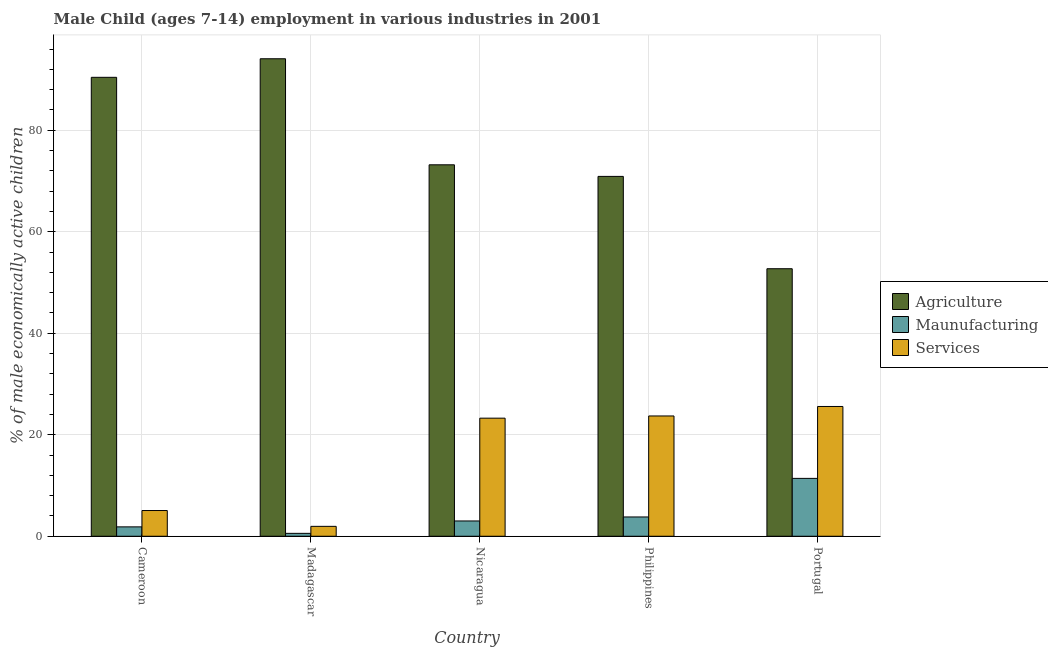How many different coloured bars are there?
Your response must be concise. 3. How many bars are there on the 2nd tick from the right?
Your response must be concise. 3. What is the label of the 1st group of bars from the left?
Ensure brevity in your answer.  Cameroon. In how many cases, is the number of bars for a given country not equal to the number of legend labels?
Offer a terse response. 0. What is the percentage of economically active children in services in Cameroon?
Offer a terse response. 5.07. Across all countries, what is the maximum percentage of economically active children in services?
Make the answer very short. 25.57. Across all countries, what is the minimum percentage of economically active children in services?
Keep it short and to the point. 1.95. In which country was the percentage of economically active children in agriculture maximum?
Make the answer very short. Madagascar. What is the total percentage of economically active children in manufacturing in the graph?
Keep it short and to the point. 20.63. What is the difference between the percentage of economically active children in agriculture in Cameroon and that in Portugal?
Offer a terse response. 37.71. What is the difference between the percentage of economically active children in services in Madagascar and the percentage of economically active children in manufacturing in Cameroon?
Provide a short and direct response. 0.1. What is the average percentage of economically active children in agriculture per country?
Make the answer very short. 76.26. What is the difference between the percentage of economically active children in manufacturing and percentage of economically active children in agriculture in Cameroon?
Your answer should be very brief. -88.57. In how many countries, is the percentage of economically active children in agriculture greater than 16 %?
Give a very brief answer. 5. What is the ratio of the percentage of economically active children in agriculture in Nicaragua to that in Portugal?
Ensure brevity in your answer.  1.39. Is the difference between the percentage of economically active children in manufacturing in Madagascar and Nicaragua greater than the difference between the percentage of economically active children in agriculture in Madagascar and Nicaragua?
Provide a short and direct response. No. What is the difference between the highest and the second highest percentage of economically active children in manufacturing?
Make the answer very short. 7.6. What is the difference between the highest and the lowest percentage of economically active children in agriculture?
Your answer should be compact. 41.37. Is the sum of the percentage of economically active children in agriculture in Cameroon and Nicaragua greater than the maximum percentage of economically active children in manufacturing across all countries?
Your answer should be very brief. Yes. What does the 2nd bar from the left in Madagascar represents?
Your response must be concise. Maunufacturing. What does the 2nd bar from the right in Cameroon represents?
Ensure brevity in your answer.  Maunufacturing. Is it the case that in every country, the sum of the percentage of economically active children in agriculture and percentage of economically active children in manufacturing is greater than the percentage of economically active children in services?
Provide a short and direct response. Yes. How many countries are there in the graph?
Ensure brevity in your answer.  5. What is the difference between two consecutive major ticks on the Y-axis?
Ensure brevity in your answer.  20. Does the graph contain any zero values?
Your response must be concise. No. Does the graph contain grids?
Make the answer very short. Yes. How are the legend labels stacked?
Provide a short and direct response. Vertical. What is the title of the graph?
Provide a short and direct response. Male Child (ages 7-14) employment in various industries in 2001. What is the label or title of the X-axis?
Keep it short and to the point. Country. What is the label or title of the Y-axis?
Your answer should be very brief. % of male economically active children. What is the % of male economically active children of Agriculture in Cameroon?
Your answer should be compact. 90.42. What is the % of male economically active children of Maunufacturing in Cameroon?
Offer a terse response. 1.85. What is the % of male economically active children of Services in Cameroon?
Give a very brief answer. 5.07. What is the % of male economically active children in Agriculture in Madagascar?
Make the answer very short. 94.08. What is the % of male economically active children in Maunufacturing in Madagascar?
Provide a short and direct response. 0.57. What is the % of male economically active children of Services in Madagascar?
Provide a succinct answer. 1.95. What is the % of male economically active children of Agriculture in Nicaragua?
Make the answer very short. 73.19. What is the % of male economically active children of Maunufacturing in Nicaragua?
Your answer should be very brief. 3.01. What is the % of male economically active children of Services in Nicaragua?
Offer a very short reply. 23.27. What is the % of male economically active children in Agriculture in Philippines?
Keep it short and to the point. 70.9. What is the % of male economically active children in Maunufacturing in Philippines?
Your answer should be very brief. 3.8. What is the % of male economically active children in Services in Philippines?
Provide a succinct answer. 23.7. What is the % of male economically active children of Agriculture in Portugal?
Offer a terse response. 52.71. What is the % of male economically active children of Maunufacturing in Portugal?
Your answer should be compact. 11.4. What is the % of male economically active children in Services in Portugal?
Give a very brief answer. 25.57. Across all countries, what is the maximum % of male economically active children in Agriculture?
Ensure brevity in your answer.  94.08. Across all countries, what is the maximum % of male economically active children in Maunufacturing?
Provide a short and direct response. 11.4. Across all countries, what is the maximum % of male economically active children in Services?
Your answer should be very brief. 25.57. Across all countries, what is the minimum % of male economically active children in Agriculture?
Your answer should be very brief. 52.71. Across all countries, what is the minimum % of male economically active children of Maunufacturing?
Offer a terse response. 0.57. Across all countries, what is the minimum % of male economically active children of Services?
Offer a very short reply. 1.95. What is the total % of male economically active children of Agriculture in the graph?
Give a very brief answer. 381.3. What is the total % of male economically active children of Maunufacturing in the graph?
Your response must be concise. 20.63. What is the total % of male economically active children in Services in the graph?
Give a very brief answer. 79.56. What is the difference between the % of male economically active children of Agriculture in Cameroon and that in Madagascar?
Make the answer very short. -3.66. What is the difference between the % of male economically active children of Maunufacturing in Cameroon and that in Madagascar?
Provide a short and direct response. 1.28. What is the difference between the % of male economically active children in Services in Cameroon and that in Madagascar?
Provide a succinct answer. 3.12. What is the difference between the % of male economically active children of Agriculture in Cameroon and that in Nicaragua?
Make the answer very short. 17.23. What is the difference between the % of male economically active children in Maunufacturing in Cameroon and that in Nicaragua?
Keep it short and to the point. -1.16. What is the difference between the % of male economically active children of Services in Cameroon and that in Nicaragua?
Your answer should be very brief. -18.2. What is the difference between the % of male economically active children in Agriculture in Cameroon and that in Philippines?
Provide a short and direct response. 19.52. What is the difference between the % of male economically active children in Maunufacturing in Cameroon and that in Philippines?
Your response must be concise. -1.95. What is the difference between the % of male economically active children of Services in Cameroon and that in Philippines?
Your answer should be very brief. -18.63. What is the difference between the % of male economically active children of Agriculture in Cameroon and that in Portugal?
Ensure brevity in your answer.  37.71. What is the difference between the % of male economically active children of Maunufacturing in Cameroon and that in Portugal?
Offer a very short reply. -9.55. What is the difference between the % of male economically active children of Services in Cameroon and that in Portugal?
Ensure brevity in your answer.  -20.5. What is the difference between the % of male economically active children of Agriculture in Madagascar and that in Nicaragua?
Your response must be concise. 20.89. What is the difference between the % of male economically active children in Maunufacturing in Madagascar and that in Nicaragua?
Give a very brief answer. -2.44. What is the difference between the % of male economically active children of Services in Madagascar and that in Nicaragua?
Your answer should be compact. -21.32. What is the difference between the % of male economically active children of Agriculture in Madagascar and that in Philippines?
Keep it short and to the point. 23.18. What is the difference between the % of male economically active children of Maunufacturing in Madagascar and that in Philippines?
Your response must be concise. -3.23. What is the difference between the % of male economically active children of Services in Madagascar and that in Philippines?
Your answer should be compact. -21.75. What is the difference between the % of male economically active children of Agriculture in Madagascar and that in Portugal?
Your response must be concise. 41.37. What is the difference between the % of male economically active children of Maunufacturing in Madagascar and that in Portugal?
Make the answer very short. -10.83. What is the difference between the % of male economically active children of Services in Madagascar and that in Portugal?
Make the answer very short. -23.62. What is the difference between the % of male economically active children of Agriculture in Nicaragua and that in Philippines?
Offer a very short reply. 2.29. What is the difference between the % of male economically active children of Maunufacturing in Nicaragua and that in Philippines?
Offer a terse response. -0.79. What is the difference between the % of male economically active children in Services in Nicaragua and that in Philippines?
Your answer should be compact. -0.43. What is the difference between the % of male economically active children in Agriculture in Nicaragua and that in Portugal?
Keep it short and to the point. 20.48. What is the difference between the % of male economically active children of Maunufacturing in Nicaragua and that in Portugal?
Keep it short and to the point. -8.39. What is the difference between the % of male economically active children of Services in Nicaragua and that in Portugal?
Provide a succinct answer. -2.3. What is the difference between the % of male economically active children in Agriculture in Philippines and that in Portugal?
Your answer should be very brief. 18.19. What is the difference between the % of male economically active children in Maunufacturing in Philippines and that in Portugal?
Your answer should be compact. -7.6. What is the difference between the % of male economically active children of Services in Philippines and that in Portugal?
Offer a very short reply. -1.87. What is the difference between the % of male economically active children in Agriculture in Cameroon and the % of male economically active children in Maunufacturing in Madagascar?
Keep it short and to the point. 89.85. What is the difference between the % of male economically active children in Agriculture in Cameroon and the % of male economically active children in Services in Madagascar?
Ensure brevity in your answer.  88.47. What is the difference between the % of male economically active children in Maunufacturing in Cameroon and the % of male economically active children in Services in Madagascar?
Your answer should be compact. -0.1. What is the difference between the % of male economically active children of Agriculture in Cameroon and the % of male economically active children of Maunufacturing in Nicaragua?
Ensure brevity in your answer.  87.41. What is the difference between the % of male economically active children in Agriculture in Cameroon and the % of male economically active children in Services in Nicaragua?
Ensure brevity in your answer.  67.15. What is the difference between the % of male economically active children of Maunufacturing in Cameroon and the % of male economically active children of Services in Nicaragua?
Give a very brief answer. -21.42. What is the difference between the % of male economically active children of Agriculture in Cameroon and the % of male economically active children of Maunufacturing in Philippines?
Your answer should be very brief. 86.62. What is the difference between the % of male economically active children of Agriculture in Cameroon and the % of male economically active children of Services in Philippines?
Offer a terse response. 66.72. What is the difference between the % of male economically active children of Maunufacturing in Cameroon and the % of male economically active children of Services in Philippines?
Your answer should be very brief. -21.85. What is the difference between the % of male economically active children of Agriculture in Cameroon and the % of male economically active children of Maunufacturing in Portugal?
Provide a short and direct response. 79.02. What is the difference between the % of male economically active children in Agriculture in Cameroon and the % of male economically active children in Services in Portugal?
Keep it short and to the point. 64.85. What is the difference between the % of male economically active children of Maunufacturing in Cameroon and the % of male economically active children of Services in Portugal?
Ensure brevity in your answer.  -23.72. What is the difference between the % of male economically active children in Agriculture in Madagascar and the % of male economically active children in Maunufacturing in Nicaragua?
Provide a succinct answer. 91.07. What is the difference between the % of male economically active children of Agriculture in Madagascar and the % of male economically active children of Services in Nicaragua?
Offer a terse response. 70.81. What is the difference between the % of male economically active children of Maunufacturing in Madagascar and the % of male economically active children of Services in Nicaragua?
Keep it short and to the point. -22.7. What is the difference between the % of male economically active children in Agriculture in Madagascar and the % of male economically active children in Maunufacturing in Philippines?
Provide a succinct answer. 90.28. What is the difference between the % of male economically active children of Agriculture in Madagascar and the % of male economically active children of Services in Philippines?
Keep it short and to the point. 70.38. What is the difference between the % of male economically active children of Maunufacturing in Madagascar and the % of male economically active children of Services in Philippines?
Your answer should be compact. -23.13. What is the difference between the % of male economically active children in Agriculture in Madagascar and the % of male economically active children in Maunufacturing in Portugal?
Ensure brevity in your answer.  82.68. What is the difference between the % of male economically active children of Agriculture in Madagascar and the % of male economically active children of Services in Portugal?
Make the answer very short. 68.51. What is the difference between the % of male economically active children of Maunufacturing in Madagascar and the % of male economically active children of Services in Portugal?
Your answer should be very brief. -25. What is the difference between the % of male economically active children of Agriculture in Nicaragua and the % of male economically active children of Maunufacturing in Philippines?
Ensure brevity in your answer.  69.39. What is the difference between the % of male economically active children of Agriculture in Nicaragua and the % of male economically active children of Services in Philippines?
Make the answer very short. 49.49. What is the difference between the % of male economically active children of Maunufacturing in Nicaragua and the % of male economically active children of Services in Philippines?
Give a very brief answer. -20.69. What is the difference between the % of male economically active children in Agriculture in Nicaragua and the % of male economically active children in Maunufacturing in Portugal?
Offer a very short reply. 61.78. What is the difference between the % of male economically active children of Agriculture in Nicaragua and the % of male economically active children of Services in Portugal?
Ensure brevity in your answer.  47.62. What is the difference between the % of male economically active children in Maunufacturing in Nicaragua and the % of male economically active children in Services in Portugal?
Your answer should be very brief. -22.56. What is the difference between the % of male economically active children of Agriculture in Philippines and the % of male economically active children of Maunufacturing in Portugal?
Offer a terse response. 59.5. What is the difference between the % of male economically active children in Agriculture in Philippines and the % of male economically active children in Services in Portugal?
Provide a short and direct response. 45.33. What is the difference between the % of male economically active children in Maunufacturing in Philippines and the % of male economically active children in Services in Portugal?
Provide a succinct answer. -21.77. What is the average % of male economically active children of Agriculture per country?
Ensure brevity in your answer.  76.26. What is the average % of male economically active children in Maunufacturing per country?
Offer a terse response. 4.13. What is the average % of male economically active children of Services per country?
Offer a very short reply. 15.91. What is the difference between the % of male economically active children of Agriculture and % of male economically active children of Maunufacturing in Cameroon?
Make the answer very short. 88.57. What is the difference between the % of male economically active children of Agriculture and % of male economically active children of Services in Cameroon?
Provide a short and direct response. 85.35. What is the difference between the % of male economically active children in Maunufacturing and % of male economically active children in Services in Cameroon?
Provide a succinct answer. -3.22. What is the difference between the % of male economically active children of Agriculture and % of male economically active children of Maunufacturing in Madagascar?
Your answer should be very brief. 93.51. What is the difference between the % of male economically active children in Agriculture and % of male economically active children in Services in Madagascar?
Give a very brief answer. 92.13. What is the difference between the % of male economically active children of Maunufacturing and % of male economically active children of Services in Madagascar?
Provide a short and direct response. -1.38. What is the difference between the % of male economically active children of Agriculture and % of male economically active children of Maunufacturing in Nicaragua?
Offer a very short reply. 70.17. What is the difference between the % of male economically active children of Agriculture and % of male economically active children of Services in Nicaragua?
Offer a terse response. 49.92. What is the difference between the % of male economically active children of Maunufacturing and % of male economically active children of Services in Nicaragua?
Your response must be concise. -20.25. What is the difference between the % of male economically active children of Agriculture and % of male economically active children of Maunufacturing in Philippines?
Your answer should be compact. 67.1. What is the difference between the % of male economically active children in Agriculture and % of male economically active children in Services in Philippines?
Provide a succinct answer. 47.2. What is the difference between the % of male economically active children of Maunufacturing and % of male economically active children of Services in Philippines?
Keep it short and to the point. -19.9. What is the difference between the % of male economically active children of Agriculture and % of male economically active children of Maunufacturing in Portugal?
Provide a short and direct response. 41.31. What is the difference between the % of male economically active children of Agriculture and % of male economically active children of Services in Portugal?
Keep it short and to the point. 27.14. What is the difference between the % of male economically active children of Maunufacturing and % of male economically active children of Services in Portugal?
Keep it short and to the point. -14.17. What is the ratio of the % of male economically active children in Agriculture in Cameroon to that in Madagascar?
Offer a terse response. 0.96. What is the ratio of the % of male economically active children in Maunufacturing in Cameroon to that in Madagascar?
Provide a short and direct response. 3.25. What is the ratio of the % of male economically active children in Services in Cameroon to that in Madagascar?
Your response must be concise. 2.6. What is the ratio of the % of male economically active children in Agriculture in Cameroon to that in Nicaragua?
Keep it short and to the point. 1.24. What is the ratio of the % of male economically active children in Maunufacturing in Cameroon to that in Nicaragua?
Your answer should be very brief. 0.61. What is the ratio of the % of male economically active children in Services in Cameroon to that in Nicaragua?
Give a very brief answer. 0.22. What is the ratio of the % of male economically active children in Agriculture in Cameroon to that in Philippines?
Provide a succinct answer. 1.28. What is the ratio of the % of male economically active children in Maunufacturing in Cameroon to that in Philippines?
Provide a succinct answer. 0.49. What is the ratio of the % of male economically active children of Services in Cameroon to that in Philippines?
Offer a terse response. 0.21. What is the ratio of the % of male economically active children of Agriculture in Cameroon to that in Portugal?
Ensure brevity in your answer.  1.72. What is the ratio of the % of male economically active children of Maunufacturing in Cameroon to that in Portugal?
Your answer should be compact. 0.16. What is the ratio of the % of male economically active children in Services in Cameroon to that in Portugal?
Give a very brief answer. 0.2. What is the ratio of the % of male economically active children of Agriculture in Madagascar to that in Nicaragua?
Your answer should be very brief. 1.29. What is the ratio of the % of male economically active children in Maunufacturing in Madagascar to that in Nicaragua?
Your answer should be compact. 0.19. What is the ratio of the % of male economically active children of Services in Madagascar to that in Nicaragua?
Your response must be concise. 0.08. What is the ratio of the % of male economically active children in Agriculture in Madagascar to that in Philippines?
Keep it short and to the point. 1.33. What is the ratio of the % of male economically active children in Maunufacturing in Madagascar to that in Philippines?
Offer a very short reply. 0.15. What is the ratio of the % of male economically active children in Services in Madagascar to that in Philippines?
Give a very brief answer. 0.08. What is the ratio of the % of male economically active children in Agriculture in Madagascar to that in Portugal?
Provide a short and direct response. 1.78. What is the ratio of the % of male economically active children of Services in Madagascar to that in Portugal?
Your answer should be very brief. 0.08. What is the ratio of the % of male economically active children in Agriculture in Nicaragua to that in Philippines?
Make the answer very short. 1.03. What is the ratio of the % of male economically active children in Maunufacturing in Nicaragua to that in Philippines?
Offer a terse response. 0.79. What is the ratio of the % of male economically active children of Services in Nicaragua to that in Philippines?
Your answer should be very brief. 0.98. What is the ratio of the % of male economically active children of Agriculture in Nicaragua to that in Portugal?
Offer a very short reply. 1.39. What is the ratio of the % of male economically active children in Maunufacturing in Nicaragua to that in Portugal?
Give a very brief answer. 0.26. What is the ratio of the % of male economically active children of Services in Nicaragua to that in Portugal?
Your answer should be compact. 0.91. What is the ratio of the % of male economically active children in Agriculture in Philippines to that in Portugal?
Offer a terse response. 1.35. What is the ratio of the % of male economically active children of Maunufacturing in Philippines to that in Portugal?
Give a very brief answer. 0.33. What is the ratio of the % of male economically active children of Services in Philippines to that in Portugal?
Give a very brief answer. 0.93. What is the difference between the highest and the second highest % of male economically active children in Agriculture?
Give a very brief answer. 3.66. What is the difference between the highest and the second highest % of male economically active children of Maunufacturing?
Your answer should be compact. 7.6. What is the difference between the highest and the second highest % of male economically active children of Services?
Keep it short and to the point. 1.87. What is the difference between the highest and the lowest % of male economically active children of Agriculture?
Offer a very short reply. 41.37. What is the difference between the highest and the lowest % of male economically active children of Maunufacturing?
Provide a short and direct response. 10.83. What is the difference between the highest and the lowest % of male economically active children in Services?
Ensure brevity in your answer.  23.62. 